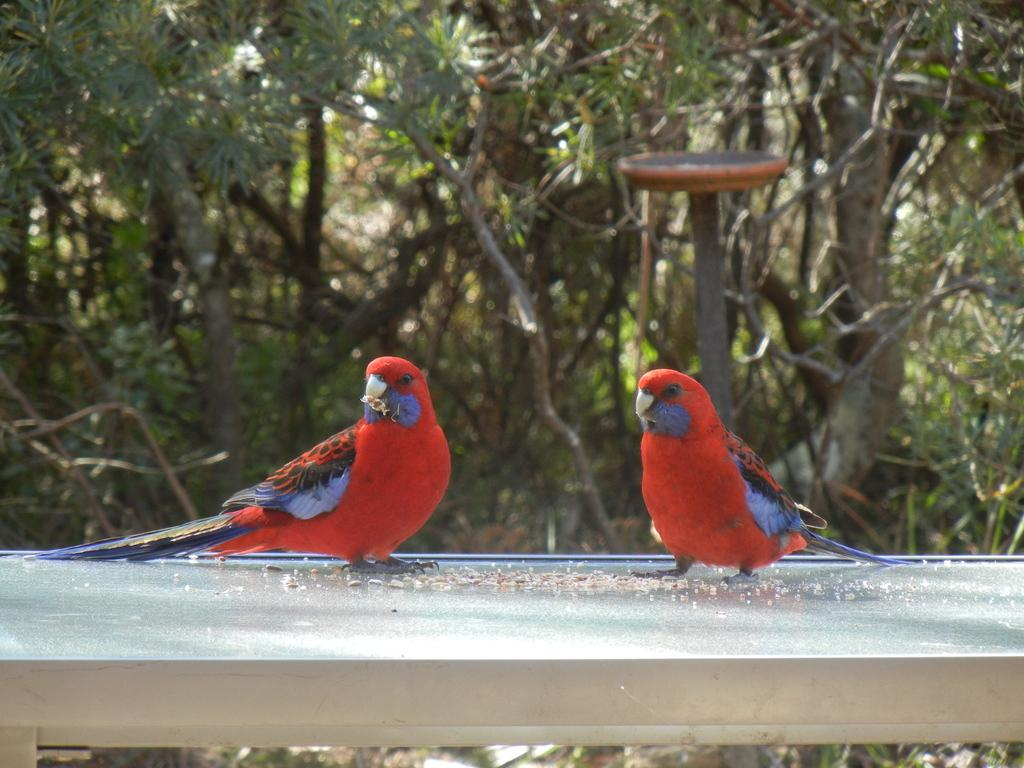What type of animals are in the foreground of the image? There are birds in the foreground of the image. What type of vegetation can be seen in the background of the image? There are trees in the background of the image. What type of humor can be seen in the image? There is no humor present in the image; it features birds in the foreground and trees in the background. How many bikes are visible in the image? There are no bikes present in the image. 